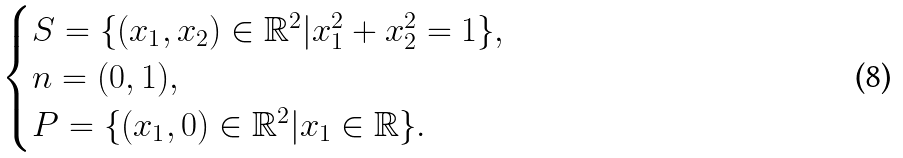Convert formula to latex. <formula><loc_0><loc_0><loc_500><loc_500>\begin{cases} S = \{ ( x _ { 1 } , x _ { 2 } ) \in \mathbb { R } ^ { 2 } | x _ { 1 } ^ { 2 } + x _ { 2 } ^ { 2 } = 1 \} , \\ n = ( 0 , 1 ) , \\ P = \{ ( x _ { 1 } , 0 ) \in \mathbb { R } ^ { 2 } | x _ { 1 } \in \mathbb { R } \} . \end{cases}</formula> 